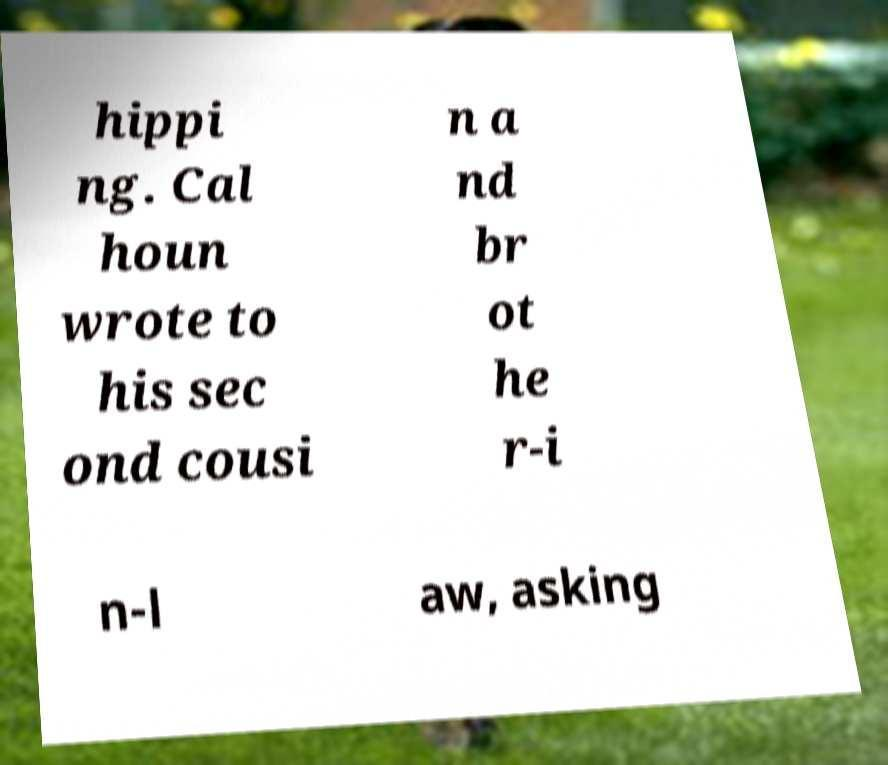Can you accurately transcribe the text from the provided image for me? hippi ng. Cal houn wrote to his sec ond cousi n a nd br ot he r-i n-l aw, asking 